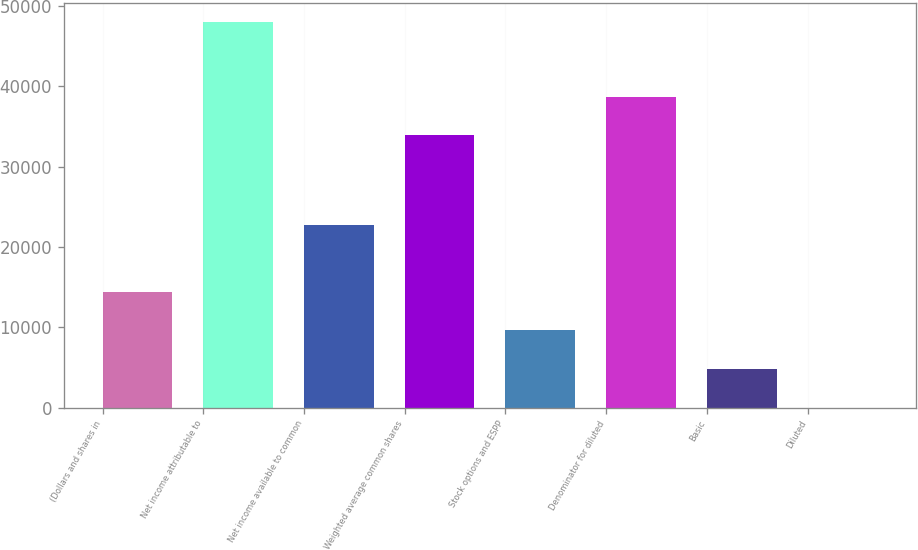Convert chart. <chart><loc_0><loc_0><loc_500><loc_500><bar_chart><fcel>(Dollars and shares in<fcel>Net income attributable to<fcel>Net income available to common<fcel>Weighted average common shares<fcel>Stock options and ESPP<fcel>Denominator for diluted<fcel>Basic<fcel>Diluted<nl><fcel>14403.5<fcel>48010<fcel>22674<fcel>33901<fcel>9602.52<fcel>38701.9<fcel>4801.59<fcel>0.66<nl></chart> 